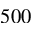Convert formula to latex. <formula><loc_0><loc_0><loc_500><loc_500>5 0 0</formula> 